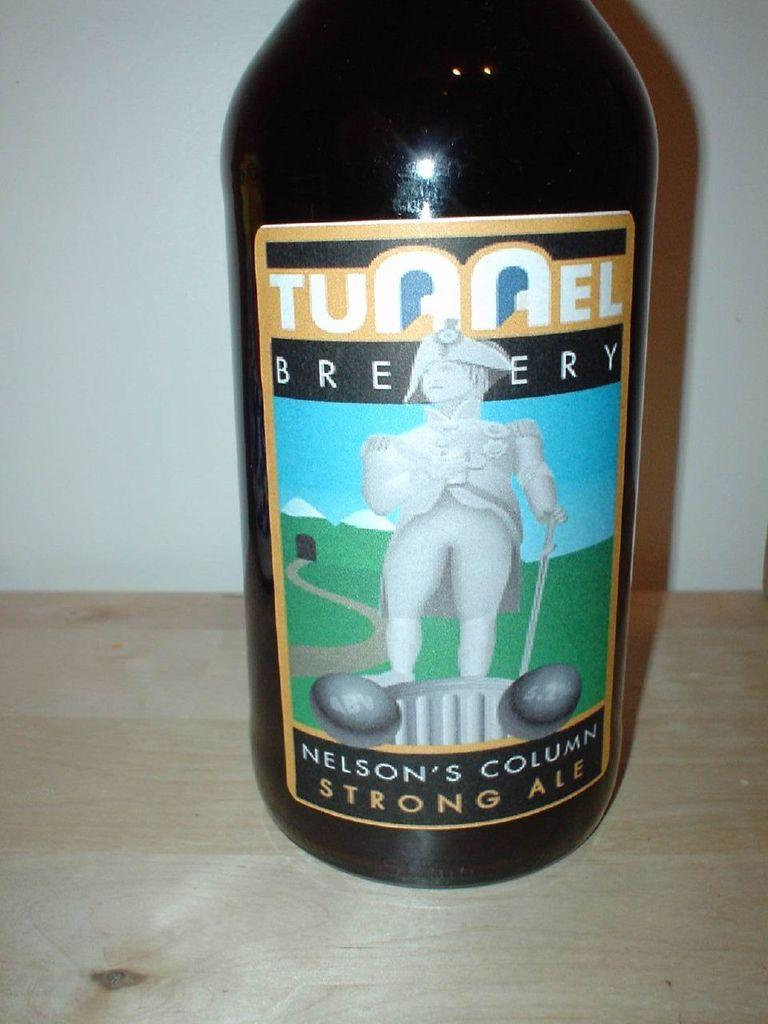Provide a one-sentence caption for the provided image. A bottle of Tunnel Brewery Nelson's Column Strong Ale. 